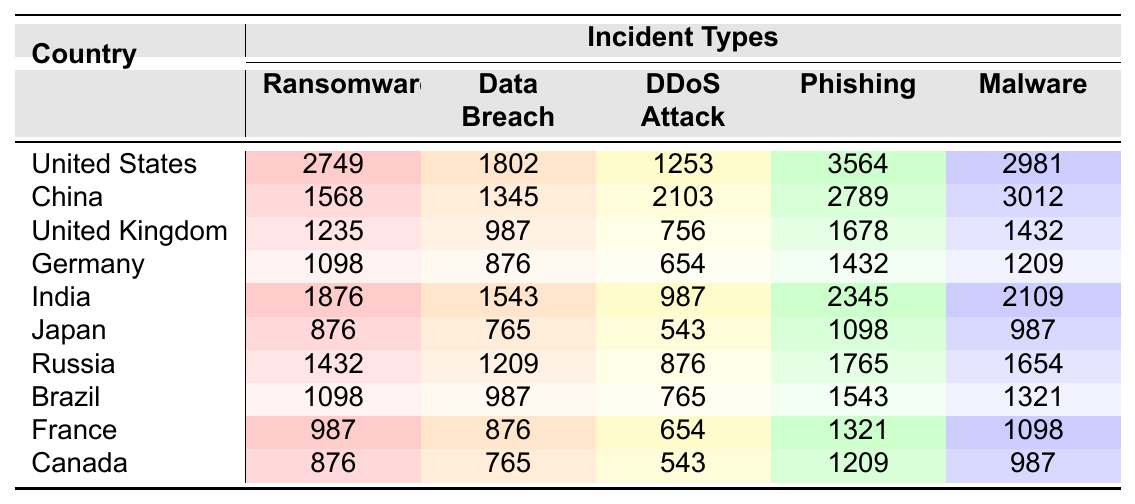What country reported the highest number of phishing incidents in 2022? The table shows that the United States reported 3564 phishing incidents, which is the highest compared to all other countries listed.
Answer: United States Which country had the least number of DDoS attacks? By looking at the DDoS Attack column, Japan reported 543 DDoS attacks, which is the least among the countries.
Answer: Japan What is the total number of ransomware incidents reported by all countries combined? To find the total, we sum the ransomware incidents for each country: 2749 + 1568 + 1235 + 1098 + 1876 + 876 + 1432 + 1098 + 987 + 876 = 12,101.
Answer: 12,101 Did China experience more data breaches than the United Kingdom in 2022? China reported 1345 data breaches while the United Kingdom reported 987, so China indeed experienced more data breaches.
Answer: Yes What is the average number of malware incidents reported by the top three countries? The top three countries by malware incidents are the United States (2981), China (3012), and India (2109). The total is 2981 + 3012 + 2109 = 8102, and the average is 8102/3 = 2700.67.
Answer: 2700.67 Which country had the highest number of total cybersecurity incidents reported? To determine the total incidents for each country, we add all incident types for each. The United States has the highest total incidents: 2749 + 1802 + 1253 + 3564 + 2981 = 12,349.
Answer: United States How many more phishing incidents did the United States report than Brazil? The United States reported 3564 phishing incidents while Brazil reported 1543. The difference is 3564 - 1543 = 2021.
Answer: 2021 Based on the table, can we say that malware incidents in Canada are higher than in France? Canada reported 987 malware incidents, while France reported 1098, meaning Canada has fewer malware incidents than France.
Answer: No What is the median number of data breaches reported by the countries? The sorted data breaches are: 765 (Japan), 876 (France, Germany), 987 (United Kingdom, Brazil), 1209 (Russia), 1345 (China), 1543 (India), and 1802 (United States). The median of these values, which has 10 data points, is the average of the 5th and 6th values: (1209 + 1345)/2 = 1277.
Answer: 1277 Did Japan report more incidents of any type compared to Germany? By comparing each incident type, Japan had fewer incidents in ransomware (876 < 1098), data breach (765 < 876), DDoS (543 < 654), phishing (1098 < 1432), and malware (987 < 1209). So, Japan did not report more incidents in any category compared to Germany.
Answer: No 